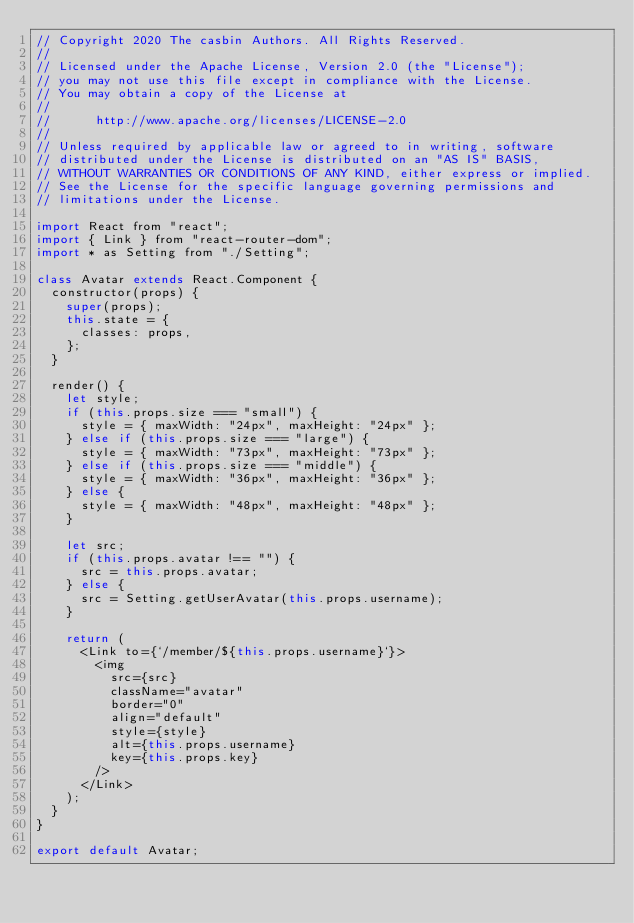<code> <loc_0><loc_0><loc_500><loc_500><_JavaScript_>// Copyright 2020 The casbin Authors. All Rights Reserved.
//
// Licensed under the Apache License, Version 2.0 (the "License");
// you may not use this file except in compliance with the License.
// You may obtain a copy of the License at
//
//      http://www.apache.org/licenses/LICENSE-2.0
//
// Unless required by applicable law or agreed to in writing, software
// distributed under the License is distributed on an "AS IS" BASIS,
// WITHOUT WARRANTIES OR CONDITIONS OF ANY KIND, either express or implied.
// See the License for the specific language governing permissions and
// limitations under the License.

import React from "react";
import { Link } from "react-router-dom";
import * as Setting from "./Setting";

class Avatar extends React.Component {
  constructor(props) {
    super(props);
    this.state = {
      classes: props,
    };
  }

  render() {
    let style;
    if (this.props.size === "small") {
      style = { maxWidth: "24px", maxHeight: "24px" };
    } else if (this.props.size === "large") {
      style = { maxWidth: "73px", maxHeight: "73px" };
    } else if (this.props.size === "middle") {
      style = { maxWidth: "36px", maxHeight: "36px" };
    } else {
      style = { maxWidth: "48px", maxHeight: "48px" };
    }

    let src;
    if (this.props.avatar !== "") {
      src = this.props.avatar;
    } else {
      src = Setting.getUserAvatar(this.props.username);
    }

    return (
      <Link to={`/member/${this.props.username}`}>
        <img
          src={src}
          className="avatar"
          border="0"
          align="default"
          style={style}
          alt={this.props.username}
          key={this.props.key}
        />
      </Link>
    );
  }
}

export default Avatar;
</code> 